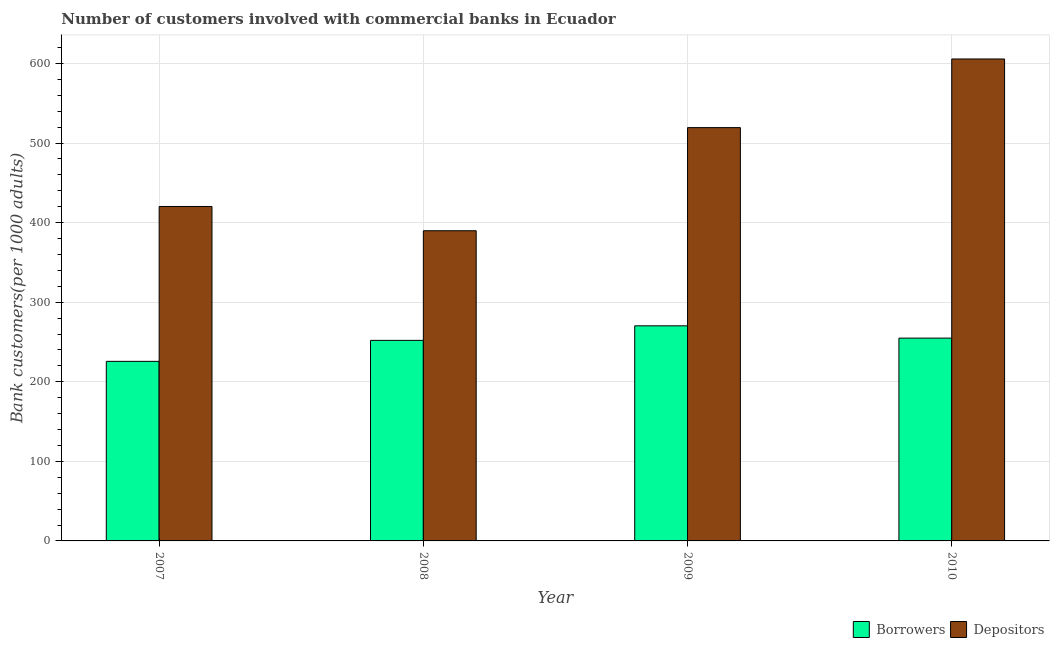How many groups of bars are there?
Your answer should be compact. 4. Are the number of bars on each tick of the X-axis equal?
Your answer should be very brief. Yes. How many bars are there on the 4th tick from the left?
Make the answer very short. 2. How many bars are there on the 4th tick from the right?
Keep it short and to the point. 2. What is the label of the 4th group of bars from the left?
Give a very brief answer. 2010. In how many cases, is the number of bars for a given year not equal to the number of legend labels?
Your answer should be very brief. 0. What is the number of borrowers in 2009?
Your response must be concise. 270.31. Across all years, what is the maximum number of borrowers?
Your answer should be very brief. 270.31. Across all years, what is the minimum number of depositors?
Provide a short and direct response. 389.78. What is the total number of borrowers in the graph?
Make the answer very short. 1002.84. What is the difference between the number of borrowers in 2007 and that in 2009?
Ensure brevity in your answer.  -44.66. What is the difference between the number of borrowers in 2010 and the number of depositors in 2007?
Your answer should be very brief. 29.2. What is the average number of borrowers per year?
Provide a short and direct response. 250.71. In the year 2009, what is the difference between the number of borrowers and number of depositors?
Keep it short and to the point. 0. What is the ratio of the number of borrowers in 2008 to that in 2009?
Your response must be concise. 0.93. Is the difference between the number of depositors in 2007 and 2008 greater than the difference between the number of borrowers in 2007 and 2008?
Give a very brief answer. No. What is the difference between the highest and the second highest number of depositors?
Keep it short and to the point. 86.27. What is the difference between the highest and the lowest number of depositors?
Ensure brevity in your answer.  215.85. What does the 1st bar from the left in 2009 represents?
Offer a terse response. Borrowers. What does the 1st bar from the right in 2008 represents?
Give a very brief answer. Depositors. How many bars are there?
Your answer should be very brief. 8. Are all the bars in the graph horizontal?
Your answer should be very brief. No. What is the difference between two consecutive major ticks on the Y-axis?
Your answer should be compact. 100. Does the graph contain any zero values?
Offer a very short reply. No. Does the graph contain grids?
Offer a very short reply. Yes. How are the legend labels stacked?
Offer a terse response. Horizontal. What is the title of the graph?
Offer a terse response. Number of customers involved with commercial banks in Ecuador. Does "Technicians" appear as one of the legend labels in the graph?
Provide a short and direct response. No. What is the label or title of the Y-axis?
Your answer should be compact. Bank customers(per 1000 adults). What is the Bank customers(per 1000 adults) of Borrowers in 2007?
Your answer should be compact. 225.65. What is the Bank customers(per 1000 adults) in Depositors in 2007?
Ensure brevity in your answer.  420.28. What is the Bank customers(per 1000 adults) in Borrowers in 2008?
Give a very brief answer. 252.02. What is the Bank customers(per 1000 adults) of Depositors in 2008?
Ensure brevity in your answer.  389.78. What is the Bank customers(per 1000 adults) in Borrowers in 2009?
Offer a terse response. 270.31. What is the Bank customers(per 1000 adults) in Depositors in 2009?
Provide a succinct answer. 519.36. What is the Bank customers(per 1000 adults) in Borrowers in 2010?
Your answer should be very brief. 254.85. What is the Bank customers(per 1000 adults) of Depositors in 2010?
Keep it short and to the point. 605.63. Across all years, what is the maximum Bank customers(per 1000 adults) of Borrowers?
Your answer should be very brief. 270.31. Across all years, what is the maximum Bank customers(per 1000 adults) of Depositors?
Your answer should be very brief. 605.63. Across all years, what is the minimum Bank customers(per 1000 adults) in Borrowers?
Offer a very short reply. 225.65. Across all years, what is the minimum Bank customers(per 1000 adults) in Depositors?
Provide a short and direct response. 389.78. What is the total Bank customers(per 1000 adults) of Borrowers in the graph?
Provide a succinct answer. 1002.84. What is the total Bank customers(per 1000 adults) of Depositors in the graph?
Your response must be concise. 1935.06. What is the difference between the Bank customers(per 1000 adults) of Borrowers in 2007 and that in 2008?
Give a very brief answer. -26.37. What is the difference between the Bank customers(per 1000 adults) in Depositors in 2007 and that in 2008?
Provide a succinct answer. 30.5. What is the difference between the Bank customers(per 1000 adults) of Borrowers in 2007 and that in 2009?
Ensure brevity in your answer.  -44.66. What is the difference between the Bank customers(per 1000 adults) of Depositors in 2007 and that in 2009?
Provide a short and direct response. -99.08. What is the difference between the Bank customers(per 1000 adults) in Borrowers in 2007 and that in 2010?
Keep it short and to the point. -29.2. What is the difference between the Bank customers(per 1000 adults) in Depositors in 2007 and that in 2010?
Your response must be concise. -185.35. What is the difference between the Bank customers(per 1000 adults) of Borrowers in 2008 and that in 2009?
Provide a succinct answer. -18.29. What is the difference between the Bank customers(per 1000 adults) in Depositors in 2008 and that in 2009?
Offer a very short reply. -129.58. What is the difference between the Bank customers(per 1000 adults) in Borrowers in 2008 and that in 2010?
Offer a terse response. -2.83. What is the difference between the Bank customers(per 1000 adults) in Depositors in 2008 and that in 2010?
Provide a short and direct response. -215.85. What is the difference between the Bank customers(per 1000 adults) in Borrowers in 2009 and that in 2010?
Provide a short and direct response. 15.46. What is the difference between the Bank customers(per 1000 adults) of Depositors in 2009 and that in 2010?
Provide a succinct answer. -86.27. What is the difference between the Bank customers(per 1000 adults) in Borrowers in 2007 and the Bank customers(per 1000 adults) in Depositors in 2008?
Your answer should be very brief. -164.13. What is the difference between the Bank customers(per 1000 adults) in Borrowers in 2007 and the Bank customers(per 1000 adults) in Depositors in 2009?
Provide a short and direct response. -293.71. What is the difference between the Bank customers(per 1000 adults) of Borrowers in 2007 and the Bank customers(per 1000 adults) of Depositors in 2010?
Keep it short and to the point. -379.98. What is the difference between the Bank customers(per 1000 adults) of Borrowers in 2008 and the Bank customers(per 1000 adults) of Depositors in 2009?
Offer a terse response. -267.34. What is the difference between the Bank customers(per 1000 adults) in Borrowers in 2008 and the Bank customers(per 1000 adults) in Depositors in 2010?
Make the answer very short. -353.61. What is the difference between the Bank customers(per 1000 adults) in Borrowers in 2009 and the Bank customers(per 1000 adults) in Depositors in 2010?
Ensure brevity in your answer.  -335.32. What is the average Bank customers(per 1000 adults) of Borrowers per year?
Your response must be concise. 250.71. What is the average Bank customers(per 1000 adults) in Depositors per year?
Ensure brevity in your answer.  483.77. In the year 2007, what is the difference between the Bank customers(per 1000 adults) of Borrowers and Bank customers(per 1000 adults) of Depositors?
Offer a terse response. -194.63. In the year 2008, what is the difference between the Bank customers(per 1000 adults) in Borrowers and Bank customers(per 1000 adults) in Depositors?
Keep it short and to the point. -137.76. In the year 2009, what is the difference between the Bank customers(per 1000 adults) of Borrowers and Bank customers(per 1000 adults) of Depositors?
Provide a succinct answer. -249.05. In the year 2010, what is the difference between the Bank customers(per 1000 adults) of Borrowers and Bank customers(per 1000 adults) of Depositors?
Offer a very short reply. -350.78. What is the ratio of the Bank customers(per 1000 adults) of Borrowers in 2007 to that in 2008?
Offer a very short reply. 0.9. What is the ratio of the Bank customers(per 1000 adults) of Depositors in 2007 to that in 2008?
Make the answer very short. 1.08. What is the ratio of the Bank customers(per 1000 adults) in Borrowers in 2007 to that in 2009?
Keep it short and to the point. 0.83. What is the ratio of the Bank customers(per 1000 adults) in Depositors in 2007 to that in 2009?
Your answer should be compact. 0.81. What is the ratio of the Bank customers(per 1000 adults) of Borrowers in 2007 to that in 2010?
Ensure brevity in your answer.  0.89. What is the ratio of the Bank customers(per 1000 adults) of Depositors in 2007 to that in 2010?
Provide a short and direct response. 0.69. What is the ratio of the Bank customers(per 1000 adults) in Borrowers in 2008 to that in 2009?
Offer a very short reply. 0.93. What is the ratio of the Bank customers(per 1000 adults) in Depositors in 2008 to that in 2009?
Offer a very short reply. 0.75. What is the ratio of the Bank customers(per 1000 adults) in Borrowers in 2008 to that in 2010?
Your answer should be very brief. 0.99. What is the ratio of the Bank customers(per 1000 adults) in Depositors in 2008 to that in 2010?
Keep it short and to the point. 0.64. What is the ratio of the Bank customers(per 1000 adults) in Borrowers in 2009 to that in 2010?
Make the answer very short. 1.06. What is the ratio of the Bank customers(per 1000 adults) of Depositors in 2009 to that in 2010?
Make the answer very short. 0.86. What is the difference between the highest and the second highest Bank customers(per 1000 adults) of Borrowers?
Your response must be concise. 15.46. What is the difference between the highest and the second highest Bank customers(per 1000 adults) in Depositors?
Provide a short and direct response. 86.27. What is the difference between the highest and the lowest Bank customers(per 1000 adults) in Borrowers?
Provide a succinct answer. 44.66. What is the difference between the highest and the lowest Bank customers(per 1000 adults) in Depositors?
Ensure brevity in your answer.  215.85. 